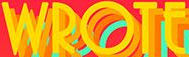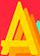Read the text from these images in sequence, separated by a semicolon. WROTE; A 